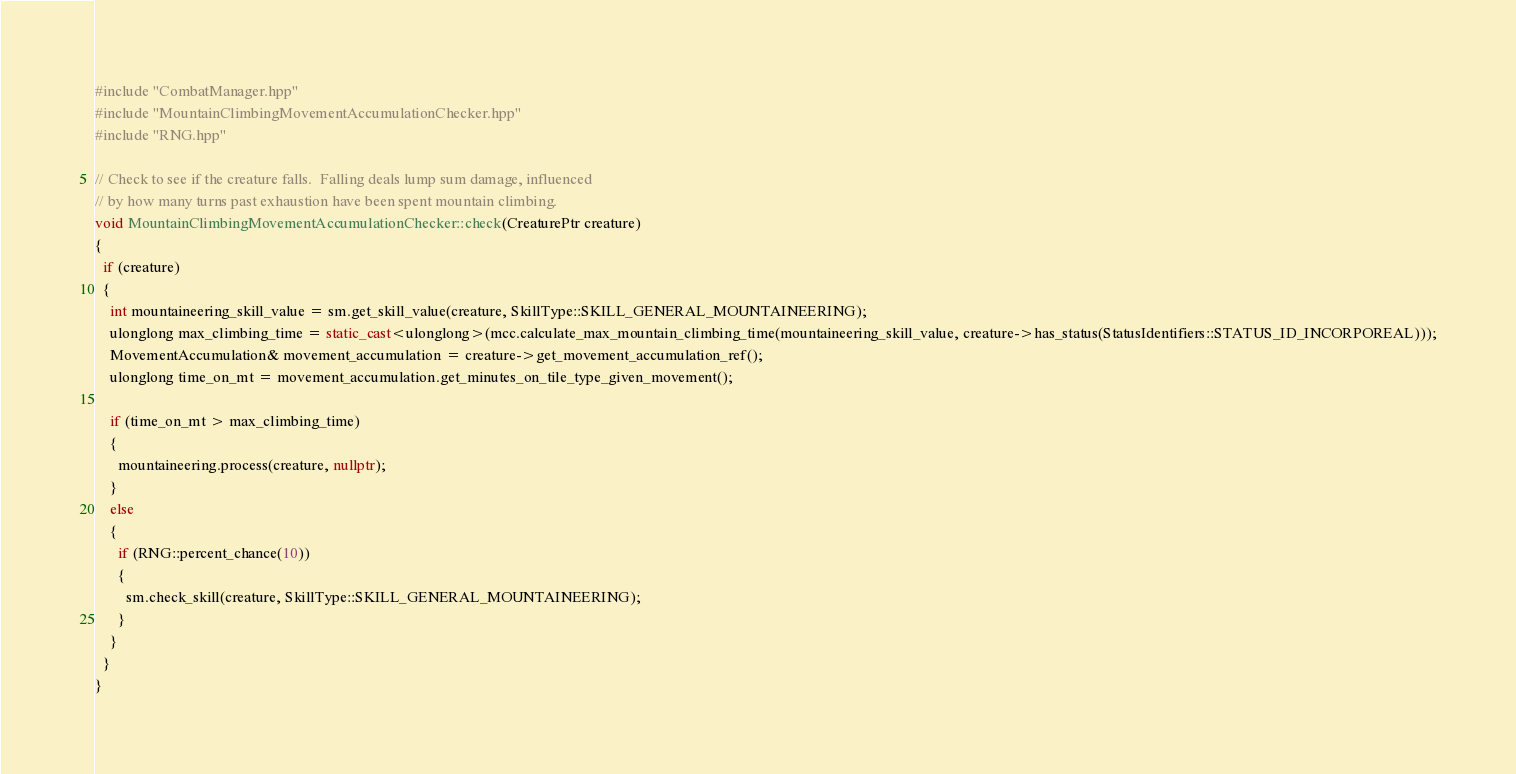<code> <loc_0><loc_0><loc_500><loc_500><_C++_>#include "CombatManager.hpp"
#include "MountainClimbingMovementAccumulationChecker.hpp"
#include "RNG.hpp"

// Check to see if the creature falls.  Falling deals lump sum damage, influenced
// by how many turns past exhaustion have been spent mountain climbing.
void MountainClimbingMovementAccumulationChecker::check(CreaturePtr creature)
{
  if (creature)
  {
    int mountaineering_skill_value = sm.get_skill_value(creature, SkillType::SKILL_GENERAL_MOUNTAINEERING);
    ulonglong max_climbing_time = static_cast<ulonglong>(mcc.calculate_max_mountain_climbing_time(mountaineering_skill_value, creature->has_status(StatusIdentifiers::STATUS_ID_INCORPOREAL)));
    MovementAccumulation& movement_accumulation = creature->get_movement_accumulation_ref();
    ulonglong time_on_mt = movement_accumulation.get_minutes_on_tile_type_given_movement();

    if (time_on_mt > max_climbing_time)
    {
      mountaineering.process(creature, nullptr);
    }
    else
    {
      if (RNG::percent_chance(10))
      {
        sm.check_skill(creature, SkillType::SKILL_GENERAL_MOUNTAINEERING);
      }
    }
  }
}
</code> 